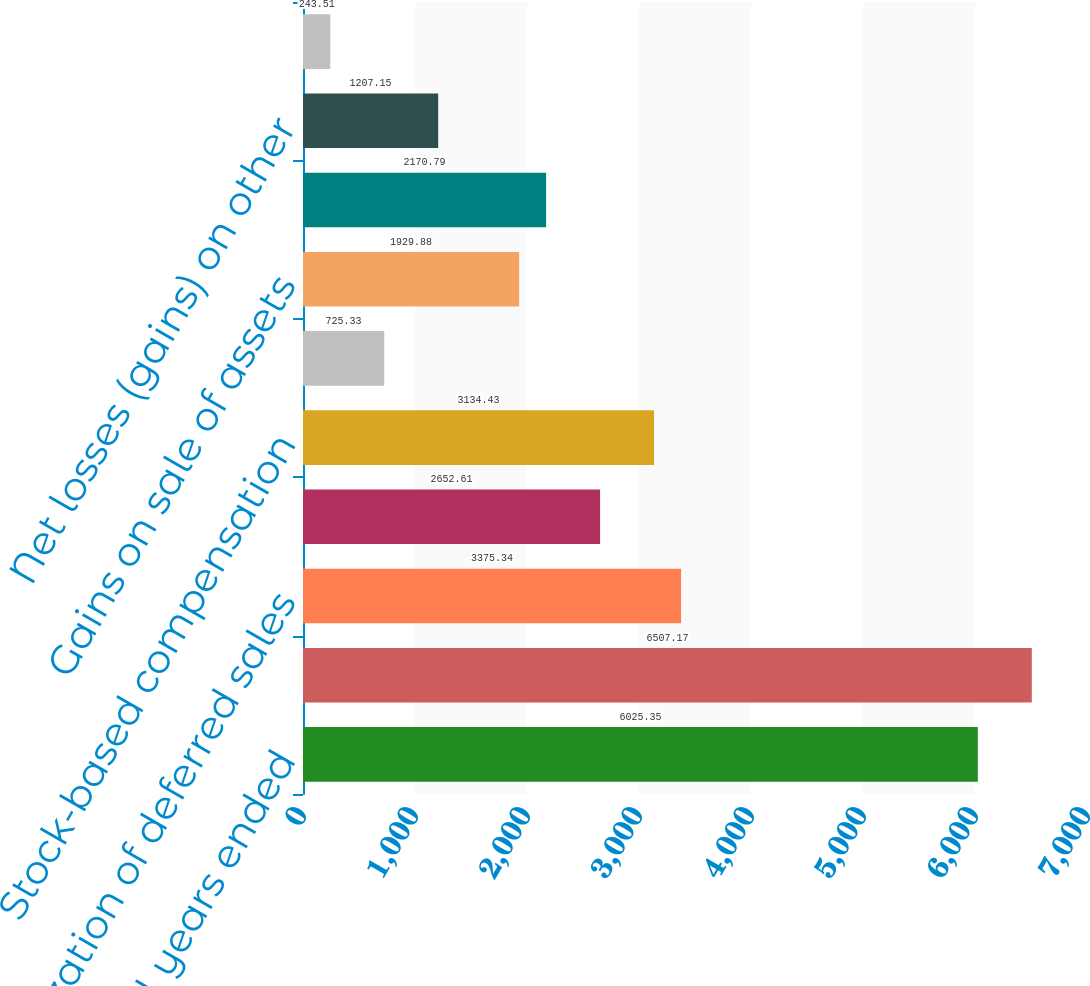<chart> <loc_0><loc_0><loc_500><loc_500><bar_chart><fcel>for the fiscal years ended<fcel>Net Income<fcel>Amortization of deferred sales<fcel>Depreciation and other<fcel>Stock-based compensation<fcel>Excess tax benefit from<fcel>Gains on sale of assets<fcel>Losses (income) from<fcel>Net losses (gains) on other<fcel>Net gains of consolidated<nl><fcel>6025.35<fcel>6507.17<fcel>3375.34<fcel>2652.61<fcel>3134.43<fcel>725.33<fcel>1929.88<fcel>2170.79<fcel>1207.15<fcel>243.51<nl></chart> 